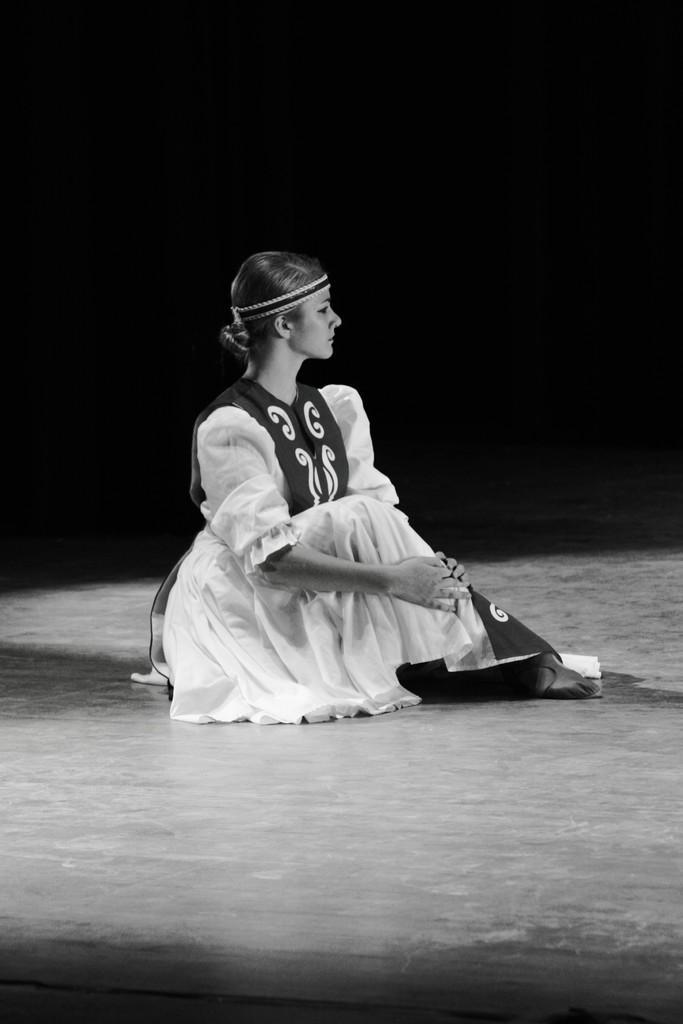Can you describe this image briefly? This is a black and white image. In the center of the image we can see a lady is sitting. At the bottom of the image we can see the floor. In the background the image is dark. 